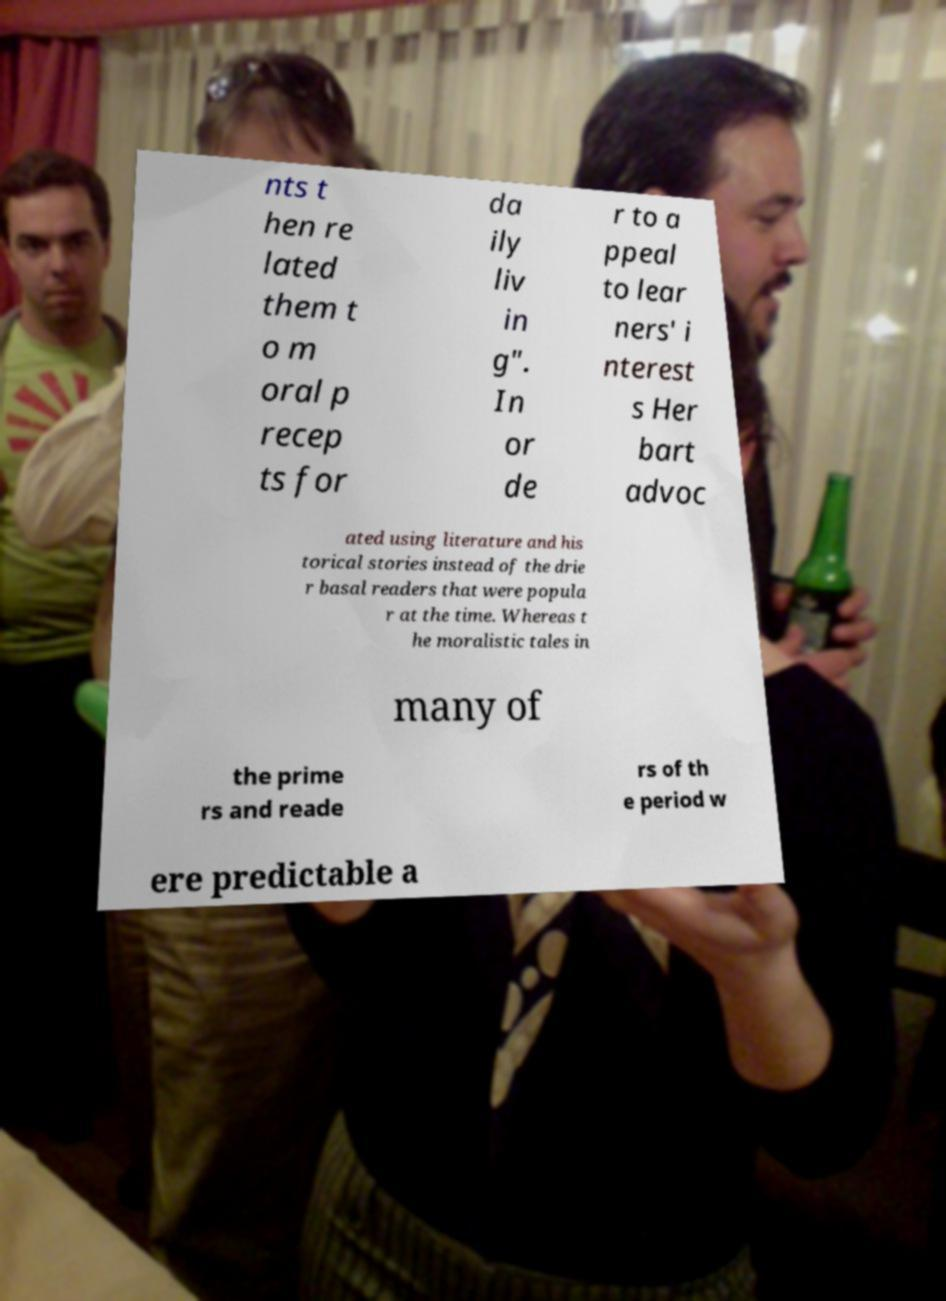Can you read and provide the text displayed in the image?This photo seems to have some interesting text. Can you extract and type it out for me? nts t hen re lated them t o m oral p recep ts for da ily liv in g". In or de r to a ppeal to lear ners' i nterest s Her bart advoc ated using literature and his torical stories instead of the drie r basal readers that were popula r at the time. Whereas t he moralistic tales in many of the prime rs and reade rs of th e period w ere predictable a 